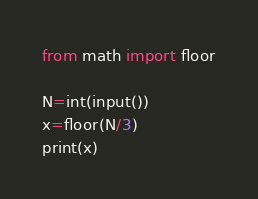<code> <loc_0><loc_0><loc_500><loc_500><_Python_>from math import floor

N=int(input())
x=floor(N/3)
print(x)</code> 